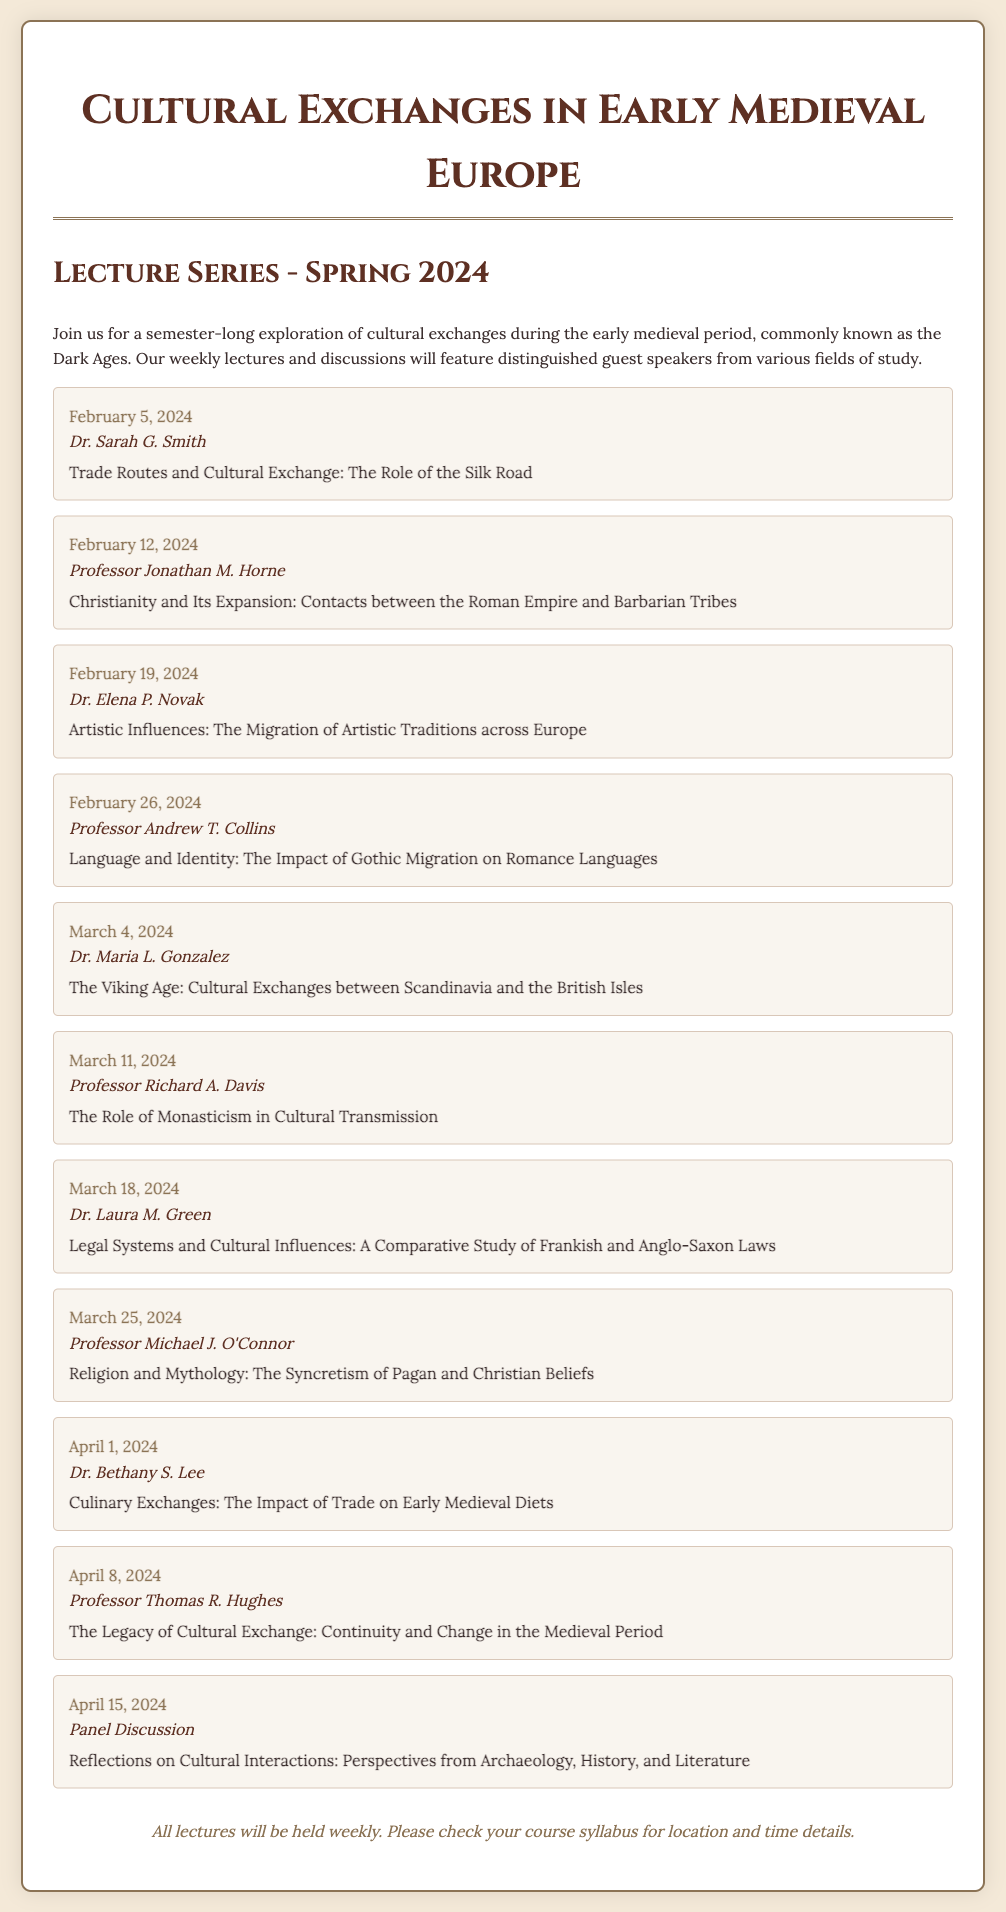What is the title of the lecture series? The title is explicitly mentioned at the top of the document.
Answer: Cultural Exchanges in Early Medieval Europe When does the lecture series begin? The starting date of the lecture series is provided in the document.
Answer: February 5, 2024 Who is the speaker for the lecture on linguistic impacts? The document lists the speaker alongside each lecture topic and date.
Answer: Professor Andrew T. Collins What is the topic of the lecture on April 8, 2024? The document provides the title for each lecture on specific dates.
Answer: The Legacy of Cultural Exchange: Continuity and Change in the Medieval Period How many lectures are planned in total? By counting the listed lectures, the total can be determined from the document.
Answer: 10 Which lecture discusses culinary exchanges? The document specifies the topic associated with each lecture date.
Answer: Culinary Exchanges: The Impact of Trade on Early Medieval Diets What type of event is scheduled for April 15, 2024? The document indicates the nature of the event as either a lecture or discussion.
Answer: Panel Discussion Who will speak about the Viking Age? The speaker's name is provided with the topic they will discuss in the document.
Answer: Dr. Maria L. Gonzalez Which topic is addressed by Professor Jonathan M. Horne? The document relates the speaker's name to a specific lecture topic.
Answer: Christianity and Its Expansion: Contacts between the Roman Empire and Barbarian Tribes 